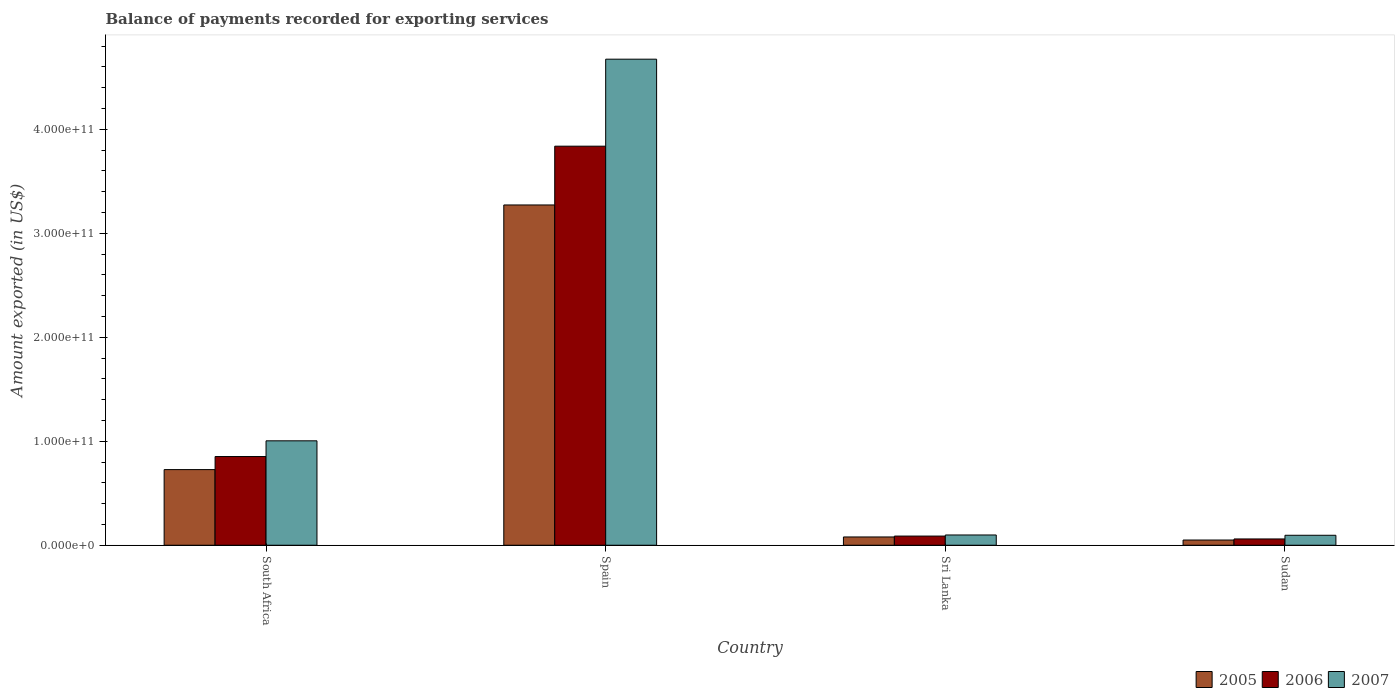How many different coloured bars are there?
Provide a succinct answer. 3. How many bars are there on the 3rd tick from the right?
Provide a succinct answer. 3. What is the label of the 1st group of bars from the left?
Offer a terse response. South Africa. In how many cases, is the number of bars for a given country not equal to the number of legend labels?
Ensure brevity in your answer.  0. What is the amount exported in 2005 in South Africa?
Ensure brevity in your answer.  7.27e+1. Across all countries, what is the maximum amount exported in 2007?
Keep it short and to the point. 4.67e+11. Across all countries, what is the minimum amount exported in 2006?
Make the answer very short. 6.04e+09. In which country was the amount exported in 2007 maximum?
Your answer should be compact. Spain. In which country was the amount exported in 2007 minimum?
Keep it short and to the point. Sudan. What is the total amount exported in 2006 in the graph?
Offer a terse response. 4.84e+11. What is the difference between the amount exported in 2005 in Spain and that in Sudan?
Your answer should be very brief. 3.22e+11. What is the difference between the amount exported in 2006 in South Africa and the amount exported in 2005 in Sri Lanka?
Provide a succinct answer. 7.73e+1. What is the average amount exported in 2006 per country?
Keep it short and to the point. 1.21e+11. What is the difference between the amount exported of/in 2007 and amount exported of/in 2006 in Sudan?
Your response must be concise. 3.54e+09. What is the ratio of the amount exported in 2006 in Spain to that in Sudan?
Your response must be concise. 63.48. What is the difference between the highest and the second highest amount exported in 2007?
Offer a terse response. -9.05e+1. What is the difference between the highest and the lowest amount exported in 2005?
Offer a terse response. 3.22e+11. In how many countries, is the amount exported in 2005 greater than the average amount exported in 2005 taken over all countries?
Give a very brief answer. 1. Is the sum of the amount exported in 2007 in South Africa and Sudan greater than the maximum amount exported in 2006 across all countries?
Ensure brevity in your answer.  No. What does the 1st bar from the right in Spain represents?
Keep it short and to the point. 2007. How many bars are there?
Provide a short and direct response. 12. Are all the bars in the graph horizontal?
Ensure brevity in your answer.  No. What is the difference between two consecutive major ticks on the Y-axis?
Offer a terse response. 1.00e+11. Where does the legend appear in the graph?
Offer a very short reply. Bottom right. How many legend labels are there?
Keep it short and to the point. 3. What is the title of the graph?
Provide a short and direct response. Balance of payments recorded for exporting services. Does "2010" appear as one of the legend labels in the graph?
Offer a terse response. No. What is the label or title of the Y-axis?
Give a very brief answer. Amount exported (in US$). What is the Amount exported (in US$) of 2005 in South Africa?
Offer a terse response. 7.27e+1. What is the Amount exported (in US$) of 2006 in South Africa?
Your answer should be compact. 8.53e+1. What is the Amount exported (in US$) of 2007 in South Africa?
Provide a succinct answer. 1.00e+11. What is the Amount exported (in US$) in 2005 in Spain?
Give a very brief answer. 3.27e+11. What is the Amount exported (in US$) in 2006 in Spain?
Offer a terse response. 3.84e+11. What is the Amount exported (in US$) of 2007 in Spain?
Your answer should be compact. 4.67e+11. What is the Amount exported (in US$) of 2005 in Sri Lanka?
Make the answer very short. 7.96e+09. What is the Amount exported (in US$) of 2006 in Sri Lanka?
Make the answer very short. 8.82e+09. What is the Amount exported (in US$) of 2007 in Sri Lanka?
Provide a short and direct response. 9.86e+09. What is the Amount exported (in US$) of 2005 in Sudan?
Provide a succinct answer. 5.02e+09. What is the Amount exported (in US$) in 2006 in Sudan?
Offer a terse response. 6.04e+09. What is the Amount exported (in US$) of 2007 in Sudan?
Your answer should be compact. 9.58e+09. Across all countries, what is the maximum Amount exported (in US$) of 2005?
Make the answer very short. 3.27e+11. Across all countries, what is the maximum Amount exported (in US$) of 2006?
Your answer should be compact. 3.84e+11. Across all countries, what is the maximum Amount exported (in US$) in 2007?
Your answer should be very brief. 4.67e+11. Across all countries, what is the minimum Amount exported (in US$) of 2005?
Offer a terse response. 5.02e+09. Across all countries, what is the minimum Amount exported (in US$) in 2006?
Make the answer very short. 6.04e+09. Across all countries, what is the minimum Amount exported (in US$) of 2007?
Offer a very short reply. 9.58e+09. What is the total Amount exported (in US$) in 2005 in the graph?
Provide a succinct answer. 4.13e+11. What is the total Amount exported (in US$) in 2006 in the graph?
Ensure brevity in your answer.  4.84e+11. What is the total Amount exported (in US$) in 2007 in the graph?
Offer a very short reply. 5.87e+11. What is the difference between the Amount exported (in US$) in 2005 in South Africa and that in Spain?
Give a very brief answer. -2.54e+11. What is the difference between the Amount exported (in US$) in 2006 in South Africa and that in Spain?
Your answer should be very brief. -2.98e+11. What is the difference between the Amount exported (in US$) in 2007 in South Africa and that in Spain?
Give a very brief answer. -3.67e+11. What is the difference between the Amount exported (in US$) of 2005 in South Africa and that in Sri Lanka?
Provide a short and direct response. 6.48e+1. What is the difference between the Amount exported (in US$) of 2006 in South Africa and that in Sri Lanka?
Keep it short and to the point. 7.65e+1. What is the difference between the Amount exported (in US$) in 2007 in South Africa and that in Sri Lanka?
Offer a very short reply. 9.05e+1. What is the difference between the Amount exported (in US$) of 2005 in South Africa and that in Sudan?
Your answer should be compact. 6.77e+1. What is the difference between the Amount exported (in US$) of 2006 in South Africa and that in Sudan?
Make the answer very short. 7.93e+1. What is the difference between the Amount exported (in US$) of 2007 in South Africa and that in Sudan?
Provide a succinct answer. 9.08e+1. What is the difference between the Amount exported (in US$) of 2005 in Spain and that in Sri Lanka?
Offer a terse response. 3.19e+11. What is the difference between the Amount exported (in US$) of 2006 in Spain and that in Sri Lanka?
Offer a terse response. 3.75e+11. What is the difference between the Amount exported (in US$) in 2007 in Spain and that in Sri Lanka?
Provide a succinct answer. 4.58e+11. What is the difference between the Amount exported (in US$) in 2005 in Spain and that in Sudan?
Your response must be concise. 3.22e+11. What is the difference between the Amount exported (in US$) in 2006 in Spain and that in Sudan?
Your answer should be very brief. 3.78e+11. What is the difference between the Amount exported (in US$) of 2007 in Spain and that in Sudan?
Offer a very short reply. 4.58e+11. What is the difference between the Amount exported (in US$) in 2005 in Sri Lanka and that in Sudan?
Make the answer very short. 2.94e+09. What is the difference between the Amount exported (in US$) of 2006 in Sri Lanka and that in Sudan?
Your response must be concise. 2.77e+09. What is the difference between the Amount exported (in US$) of 2007 in Sri Lanka and that in Sudan?
Give a very brief answer. 2.82e+08. What is the difference between the Amount exported (in US$) in 2005 in South Africa and the Amount exported (in US$) in 2006 in Spain?
Make the answer very short. -3.11e+11. What is the difference between the Amount exported (in US$) in 2005 in South Africa and the Amount exported (in US$) in 2007 in Spain?
Your answer should be very brief. -3.95e+11. What is the difference between the Amount exported (in US$) in 2006 in South Africa and the Amount exported (in US$) in 2007 in Spain?
Offer a very short reply. -3.82e+11. What is the difference between the Amount exported (in US$) of 2005 in South Africa and the Amount exported (in US$) of 2006 in Sri Lanka?
Provide a short and direct response. 6.39e+1. What is the difference between the Amount exported (in US$) in 2005 in South Africa and the Amount exported (in US$) in 2007 in Sri Lanka?
Keep it short and to the point. 6.29e+1. What is the difference between the Amount exported (in US$) in 2006 in South Africa and the Amount exported (in US$) in 2007 in Sri Lanka?
Keep it short and to the point. 7.54e+1. What is the difference between the Amount exported (in US$) in 2005 in South Africa and the Amount exported (in US$) in 2006 in Sudan?
Your answer should be very brief. 6.67e+1. What is the difference between the Amount exported (in US$) in 2005 in South Africa and the Amount exported (in US$) in 2007 in Sudan?
Your answer should be very brief. 6.31e+1. What is the difference between the Amount exported (in US$) in 2006 in South Africa and the Amount exported (in US$) in 2007 in Sudan?
Offer a very short reply. 7.57e+1. What is the difference between the Amount exported (in US$) of 2005 in Spain and the Amount exported (in US$) of 2006 in Sri Lanka?
Offer a very short reply. 3.18e+11. What is the difference between the Amount exported (in US$) in 2005 in Spain and the Amount exported (in US$) in 2007 in Sri Lanka?
Offer a terse response. 3.17e+11. What is the difference between the Amount exported (in US$) in 2006 in Spain and the Amount exported (in US$) in 2007 in Sri Lanka?
Keep it short and to the point. 3.74e+11. What is the difference between the Amount exported (in US$) of 2005 in Spain and the Amount exported (in US$) of 2006 in Sudan?
Offer a terse response. 3.21e+11. What is the difference between the Amount exported (in US$) of 2005 in Spain and the Amount exported (in US$) of 2007 in Sudan?
Offer a very short reply. 3.18e+11. What is the difference between the Amount exported (in US$) in 2006 in Spain and the Amount exported (in US$) in 2007 in Sudan?
Offer a very short reply. 3.74e+11. What is the difference between the Amount exported (in US$) of 2005 in Sri Lanka and the Amount exported (in US$) of 2006 in Sudan?
Your answer should be very brief. 1.92e+09. What is the difference between the Amount exported (in US$) in 2005 in Sri Lanka and the Amount exported (in US$) in 2007 in Sudan?
Ensure brevity in your answer.  -1.62e+09. What is the difference between the Amount exported (in US$) of 2006 in Sri Lanka and the Amount exported (in US$) of 2007 in Sudan?
Provide a short and direct response. -7.63e+08. What is the average Amount exported (in US$) in 2005 per country?
Keep it short and to the point. 1.03e+11. What is the average Amount exported (in US$) in 2006 per country?
Ensure brevity in your answer.  1.21e+11. What is the average Amount exported (in US$) in 2007 per country?
Make the answer very short. 1.47e+11. What is the difference between the Amount exported (in US$) of 2005 and Amount exported (in US$) of 2006 in South Africa?
Offer a terse response. -1.26e+1. What is the difference between the Amount exported (in US$) in 2005 and Amount exported (in US$) in 2007 in South Africa?
Give a very brief answer. -2.77e+1. What is the difference between the Amount exported (in US$) of 2006 and Amount exported (in US$) of 2007 in South Africa?
Make the answer very short. -1.51e+1. What is the difference between the Amount exported (in US$) of 2005 and Amount exported (in US$) of 2006 in Spain?
Your answer should be very brief. -5.65e+1. What is the difference between the Amount exported (in US$) of 2005 and Amount exported (in US$) of 2007 in Spain?
Ensure brevity in your answer.  -1.40e+11. What is the difference between the Amount exported (in US$) in 2006 and Amount exported (in US$) in 2007 in Spain?
Your answer should be very brief. -8.37e+1. What is the difference between the Amount exported (in US$) of 2005 and Amount exported (in US$) of 2006 in Sri Lanka?
Offer a terse response. -8.56e+08. What is the difference between the Amount exported (in US$) in 2005 and Amount exported (in US$) in 2007 in Sri Lanka?
Your answer should be very brief. -1.90e+09. What is the difference between the Amount exported (in US$) of 2006 and Amount exported (in US$) of 2007 in Sri Lanka?
Keep it short and to the point. -1.04e+09. What is the difference between the Amount exported (in US$) of 2005 and Amount exported (in US$) of 2006 in Sudan?
Offer a very short reply. -1.03e+09. What is the difference between the Amount exported (in US$) of 2005 and Amount exported (in US$) of 2007 in Sudan?
Ensure brevity in your answer.  -4.56e+09. What is the difference between the Amount exported (in US$) of 2006 and Amount exported (in US$) of 2007 in Sudan?
Provide a short and direct response. -3.54e+09. What is the ratio of the Amount exported (in US$) of 2005 in South Africa to that in Spain?
Offer a very short reply. 0.22. What is the ratio of the Amount exported (in US$) of 2006 in South Africa to that in Spain?
Offer a terse response. 0.22. What is the ratio of the Amount exported (in US$) in 2007 in South Africa to that in Spain?
Make the answer very short. 0.21. What is the ratio of the Amount exported (in US$) in 2005 in South Africa to that in Sri Lanka?
Your answer should be compact. 9.13. What is the ratio of the Amount exported (in US$) of 2006 in South Africa to that in Sri Lanka?
Offer a very short reply. 9.67. What is the ratio of the Amount exported (in US$) of 2007 in South Africa to that in Sri Lanka?
Provide a short and direct response. 10.18. What is the ratio of the Amount exported (in US$) of 2005 in South Africa to that in Sudan?
Your answer should be very brief. 14.49. What is the ratio of the Amount exported (in US$) of 2006 in South Africa to that in Sudan?
Offer a terse response. 14.11. What is the ratio of the Amount exported (in US$) of 2007 in South Africa to that in Sudan?
Your answer should be compact. 10.48. What is the ratio of the Amount exported (in US$) of 2005 in Spain to that in Sri Lanka?
Offer a terse response. 41.09. What is the ratio of the Amount exported (in US$) in 2006 in Spain to that in Sri Lanka?
Your answer should be compact. 43.51. What is the ratio of the Amount exported (in US$) in 2007 in Spain to that in Sri Lanka?
Your response must be concise. 47.38. What is the ratio of the Amount exported (in US$) of 2005 in Spain to that in Sudan?
Provide a short and direct response. 65.19. What is the ratio of the Amount exported (in US$) in 2006 in Spain to that in Sudan?
Offer a terse response. 63.48. What is the ratio of the Amount exported (in US$) of 2007 in Spain to that in Sudan?
Give a very brief answer. 48.78. What is the ratio of the Amount exported (in US$) in 2005 in Sri Lanka to that in Sudan?
Your answer should be compact. 1.59. What is the ratio of the Amount exported (in US$) of 2006 in Sri Lanka to that in Sudan?
Provide a short and direct response. 1.46. What is the ratio of the Amount exported (in US$) of 2007 in Sri Lanka to that in Sudan?
Ensure brevity in your answer.  1.03. What is the difference between the highest and the second highest Amount exported (in US$) of 2005?
Provide a short and direct response. 2.54e+11. What is the difference between the highest and the second highest Amount exported (in US$) of 2006?
Offer a terse response. 2.98e+11. What is the difference between the highest and the second highest Amount exported (in US$) in 2007?
Offer a very short reply. 3.67e+11. What is the difference between the highest and the lowest Amount exported (in US$) in 2005?
Your answer should be very brief. 3.22e+11. What is the difference between the highest and the lowest Amount exported (in US$) in 2006?
Make the answer very short. 3.78e+11. What is the difference between the highest and the lowest Amount exported (in US$) in 2007?
Provide a short and direct response. 4.58e+11. 